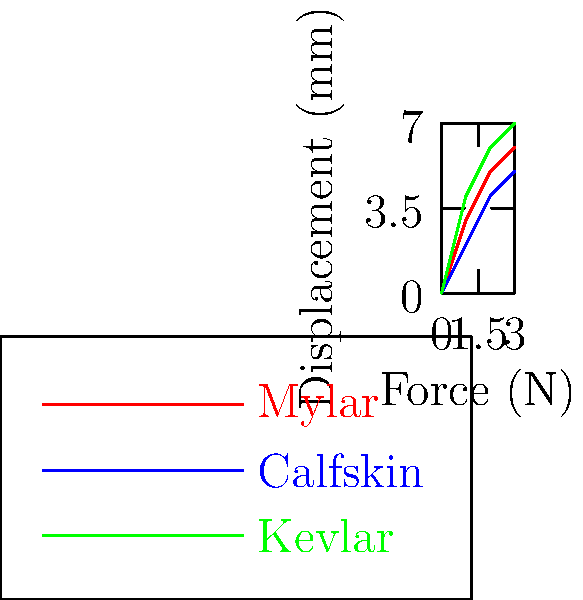As an aspiring rock band drummer, you're curious about different drumhead materials. The graph shows the force-displacement relationship for three common drumhead materials: Mylar, Calfskin, and Kevlar. Which material would produce the brightest, most resonant sound, and why? To determine which material would produce the brightest, most resonant sound, we need to consider the stiffness of each material. The stiffness is related to the slope of the force-displacement curve:

1. Analyze the graph:
   - Steeper slope = higher stiffness
   - Mylar (red): moderate slope
   - Calfskin (blue): lowest slope
   - Kevlar (green): steepest slope

2. Understand the relationship between stiffness and sound:
   - Stiffer materials vibrate at higher frequencies
   - Higher frequencies produce brighter, more resonant sounds

3. Compare the materials:
   - Kevlar has the steepest slope, indicating the highest stiffness
   - Mylar has a moderate slope, indicating medium stiffness
   - Calfskin has the lowest slope, indicating the lowest stiffness

4. Consider the effect on sound:
   - Kevlar will produce the highest frequency vibrations
   - Higher frequency vibrations result in brighter, more resonant sounds

5. Apply to drumming:
   - Kevlar drumheads will produce the brightest, most resonant sound
   - This can be desirable for certain styles of rock music

The stiffness of a material can be quantified using Hooke's Law: $F = kx$, where $k$ is the spring constant (stiffness). A higher $k$ value corresponds to a steeper slope in the force-displacement graph.
Answer: Kevlar, due to its highest stiffness. 